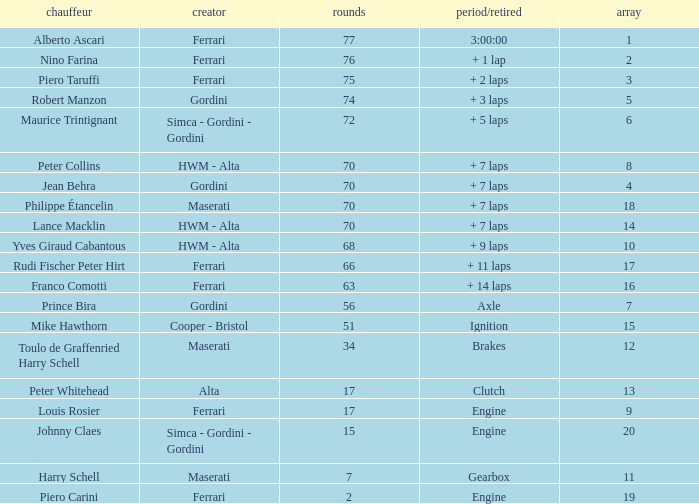Who drove the car with over 66 laps with a grid of 5? Robert Manzon. 